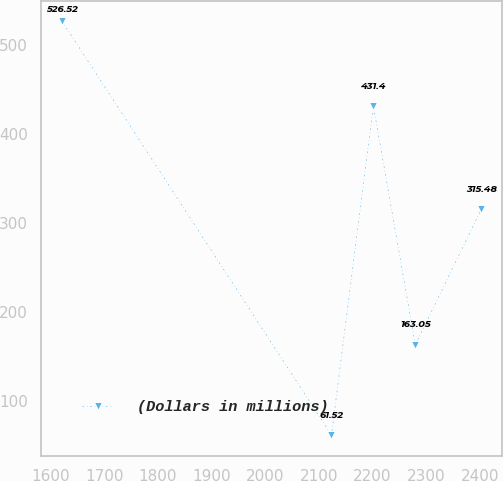Convert chart to OTSL. <chart><loc_0><loc_0><loc_500><loc_500><line_chart><ecel><fcel>(Dollars in millions)<nl><fcel>1621.21<fcel>526.52<nl><fcel>2123.28<fcel>61.52<nl><fcel>2201.44<fcel>431.4<nl><fcel>2279.6<fcel>163.05<nl><fcel>2402.79<fcel>315.48<nl></chart> 